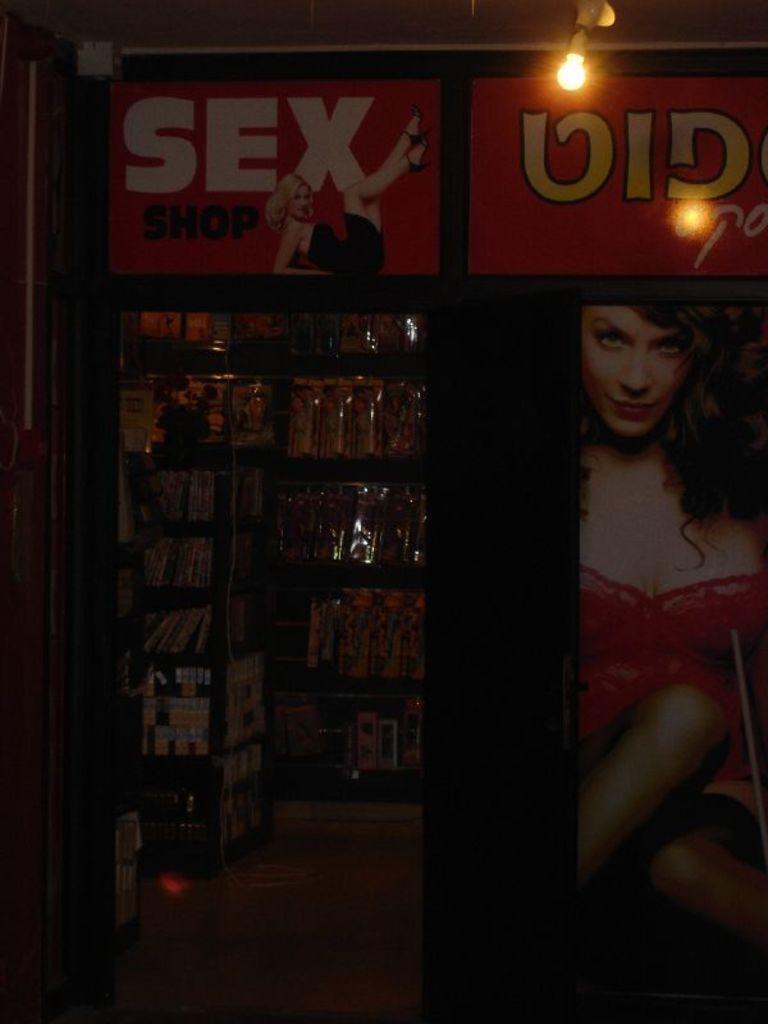Could you give a brief overview of what you see in this image? In this image, we can see a store. Here there are few banners and light. On the left side of the image, we can see the inside view of a store. Here there are few objects and floor. 